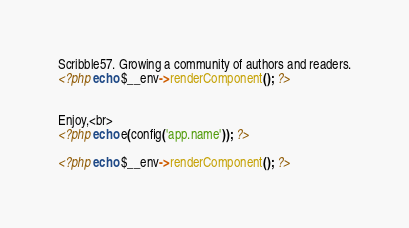<code> <loc_0><loc_0><loc_500><loc_500><_PHP_>Scribble57. Growing a community of authors and readers.
<?php echo $__env->renderComponent(); ?>


Enjoy,<br>
<?php echo e(config('app.name')); ?>

<?php echo $__env->renderComponent(); ?>
</code> 